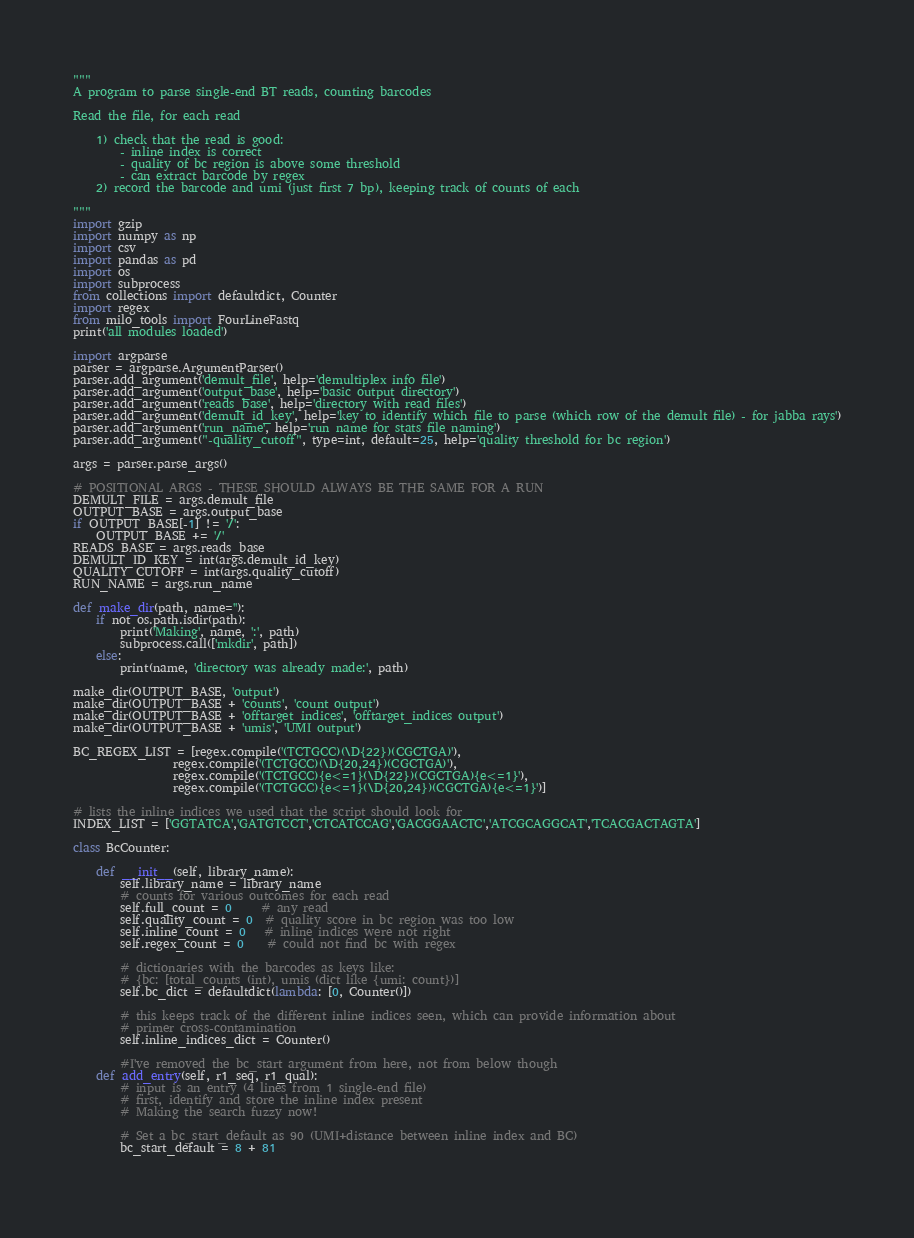<code> <loc_0><loc_0><loc_500><loc_500><_Python_>"""
A program to parse single-end BT reads, counting barcodes

Read the file, for each read

    1) check that the read is good:
        - inline index is correct
        - quality of bc region is above some threshold
        - can extract barcode by regex
    2) record the barcode and umi (just first 7 bp), keeping track of counts of each

"""
import gzip
import numpy as np
import csv
import pandas as pd
import os
import subprocess
from collections import defaultdict, Counter
import regex
from milo_tools import FourLineFastq
print('all modules loaded')

import argparse
parser = argparse.ArgumentParser()
parser.add_argument('demult_file', help='demultiplex info file')
parser.add_argument('output_base', help='basic output directory')
parser.add_argument('reads_base', help='directory with read files')
parser.add_argument('demult_id_key', help='key to identify which file to parse (which row of the demult file) - for jabba rays')
parser.add_argument('run_name', help='run name for stats file naming')
parser.add_argument("-quality_cutoff", type=int, default=25, help='quality threshold for bc region')

args = parser.parse_args()

# POSITIONAL ARGS - THESE SHOULD ALWAYS BE THE SAME FOR A RUN
DEMULT_FILE = args.demult_file
OUTPUT_BASE = args.output_base
if OUTPUT_BASE[-1] != '/':
    OUTPUT_BASE += '/'
READS_BASE = args.reads_base
DEMULT_ID_KEY = int(args.demult_id_key)
QUALITY_CUTOFF = int(args.quality_cutoff)
RUN_NAME = args.run_name

def make_dir(path, name=''):
    if not os.path.isdir(path):
        print('Making', name, ':', path)
        subprocess.call(['mkdir', path])
    else:
        print(name, 'directory was already made:', path)

make_dir(OUTPUT_BASE, 'output')
make_dir(OUTPUT_BASE + 'counts', 'count output')
make_dir(OUTPUT_BASE + 'offtarget_indices', 'offtarget_indices output')
make_dir(OUTPUT_BASE + 'umis', 'UMI output')

BC_REGEX_LIST = [regex.compile('(TCTGCC)(\D{22})(CGCTGA)'),
                 regex.compile('(TCTGCC)(\D{20,24})(CGCTGA)'),
                 regex.compile('(TCTGCC){e<=1}(\D{22})(CGCTGA){e<=1}'),
                 regex.compile('(TCTGCC){e<=1}(\D{20,24})(CGCTGA){e<=1}')]

# lists the inline indices we used that the script should look for
INDEX_LIST = ['GGTATCA','GATGTCCT','CTCATCCAG','GACGGAACTC','ATCGCAGGCAT','TCACGACTAGTA']

class BcCounter:

    def __init__(self, library_name):
        self.library_name = library_name
        # counts for various outcomes for each read
        self.full_count = 0     # any read
        self.quality_count = 0  # quality score in bc region was too low
        self.inline_count = 0   # inline indices were not right
        self.regex_count = 0    # could not find bc with regex

        # dictionaries with the barcodes as keys like:
        # {bc: [total_counts (int), umis (dict like {umi: count})]
        self.bc_dict = defaultdict(lambda: [0, Counter()])

        # this keeps track of the different inline indices seen, which can provide information about
        # primer cross-contamination
        self.inline_indices_dict = Counter()

        #I've removed the bc_start argument from here, not from below though
    def add_entry(self, r1_seq, r1_qual):
        # input is an entry (4 lines from 1 single-end file)
        # first, identify and store the inline index present
        # Making the search fuzzy now!

        # Set a bc_start_default as 90 (UMI+distance between inline index and BC)
        bc_start_default = 8 + 81
        </code> 